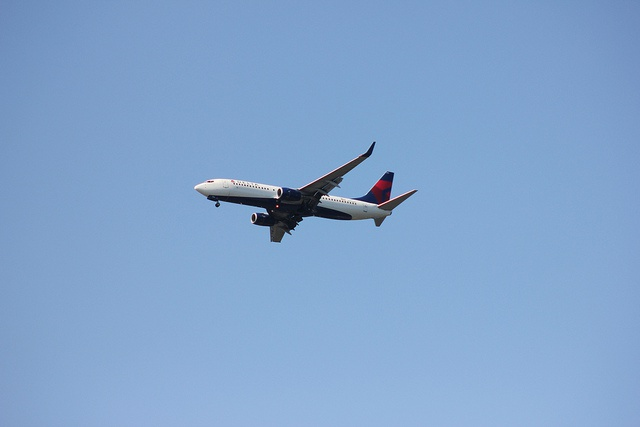Describe the objects in this image and their specific colors. I can see a airplane in gray, black, lightgray, and darkgray tones in this image. 